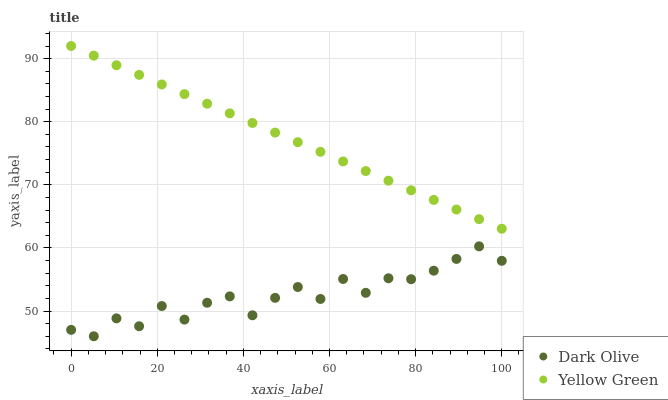Does Dark Olive have the minimum area under the curve?
Answer yes or no. Yes. Does Yellow Green have the maximum area under the curve?
Answer yes or no. Yes. Does Yellow Green have the minimum area under the curve?
Answer yes or no. No. Is Yellow Green the smoothest?
Answer yes or no. Yes. Is Dark Olive the roughest?
Answer yes or no. Yes. Is Yellow Green the roughest?
Answer yes or no. No. Does Dark Olive have the lowest value?
Answer yes or no. Yes. Does Yellow Green have the lowest value?
Answer yes or no. No. Does Yellow Green have the highest value?
Answer yes or no. Yes. Is Dark Olive less than Yellow Green?
Answer yes or no. Yes. Is Yellow Green greater than Dark Olive?
Answer yes or no. Yes. Does Dark Olive intersect Yellow Green?
Answer yes or no. No. 